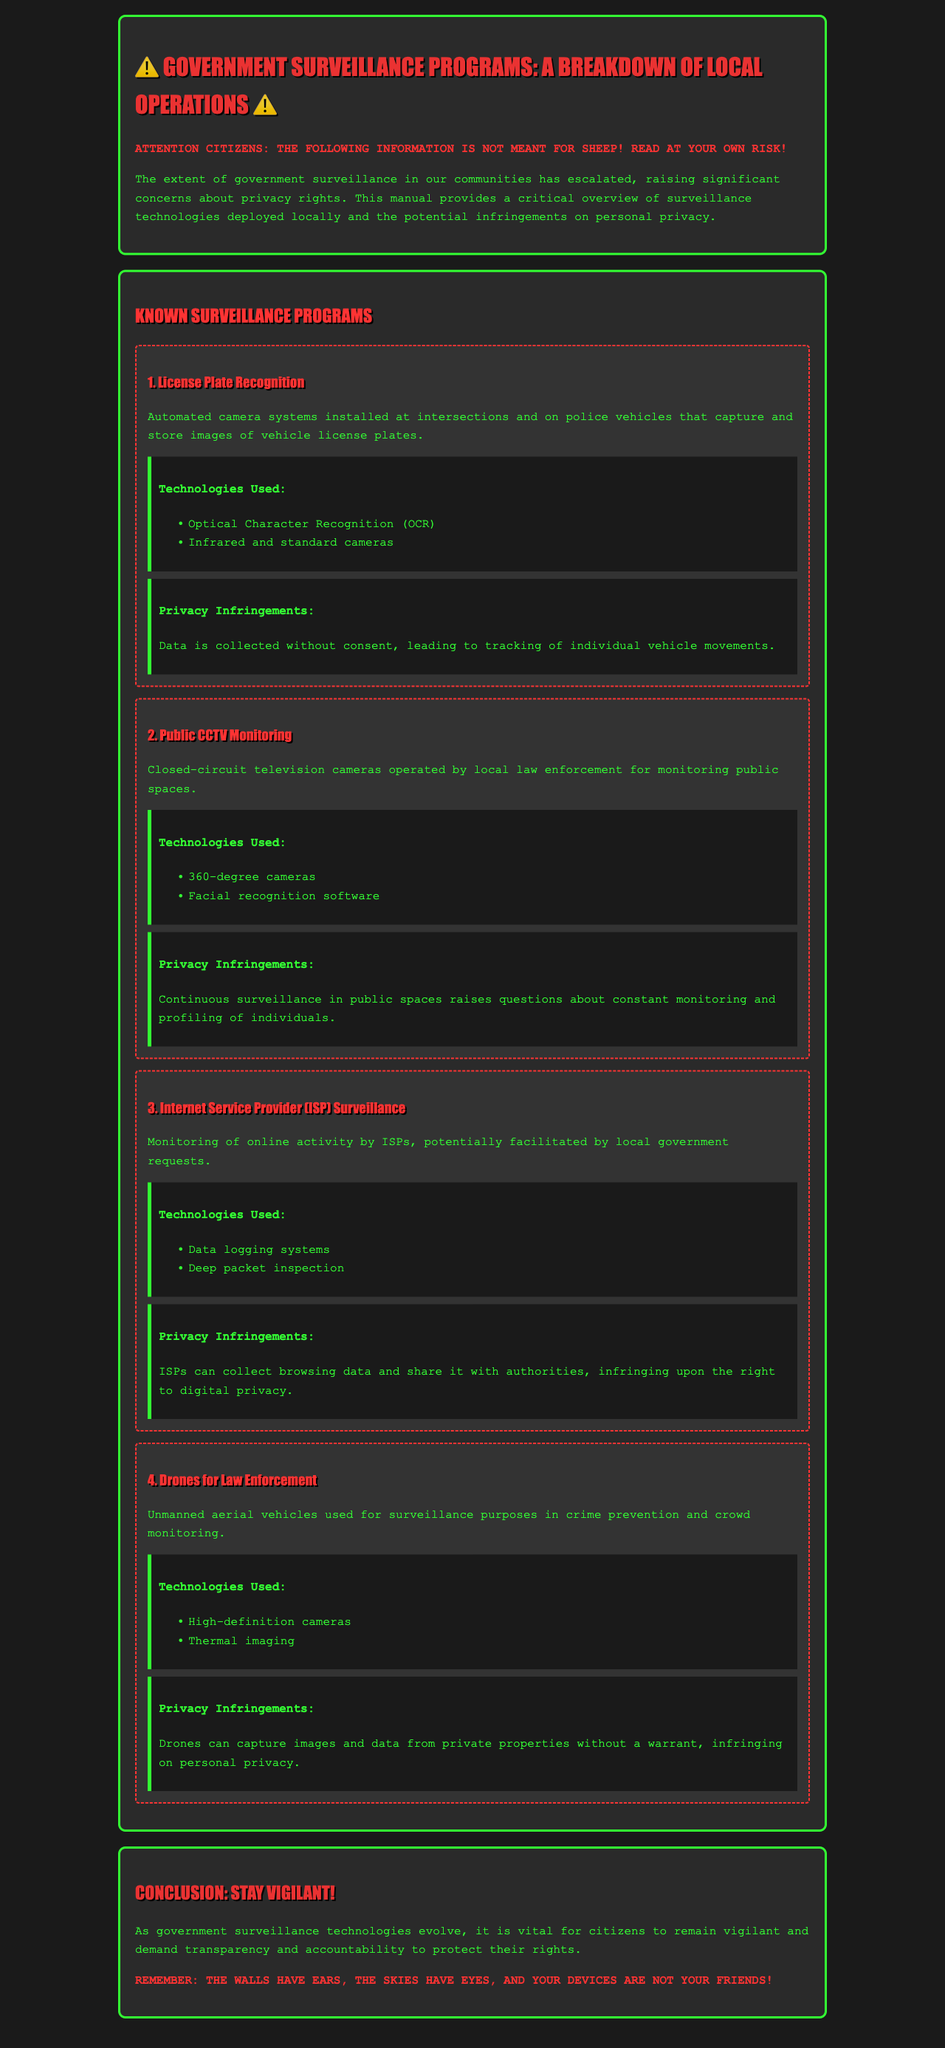what is the first surveillance program mentioned? The document lists "License Plate Recognition" as the first surveillance program.
Answer: License Plate Recognition how many technologies are listed for the Public CCTV Monitoring program? The document specifies two technologies used for the Public CCTV Monitoring program.
Answer: 2 what technology is used for capturing vehicle license plates? The technology used is Optical Character Recognition.
Answer: Optical Character Recognition what privacy infringement is associated with drone surveillance? The document states that drones can capture images and data from private properties without a warrant.
Answer: Images and data from private properties without a warrant which surveillance program involves monitoring online activity? The program that involves monitoring online activity is Internet Service Provider (ISP) Surveillance.
Answer: Internet Service Provider (ISP) Surveillance what is a potential consequence of the data collected by License Plate Recognition? The consequence is tracking of individual vehicle movements as mentioned in the document.
Answer: Tracking of individual vehicle movements how are individuals profiled according to the Public CCTV Monitoring program? Continuous surveillance in public spaces leads to profiling of individuals as stated in the document.
Answer: Profiling of individuals what is the conclusion about government surveillance technologies? The conclusion emphasizes the importance of citizens remaining vigilant and demanding transparency and accountability.
Answer: Stay vigilant! 